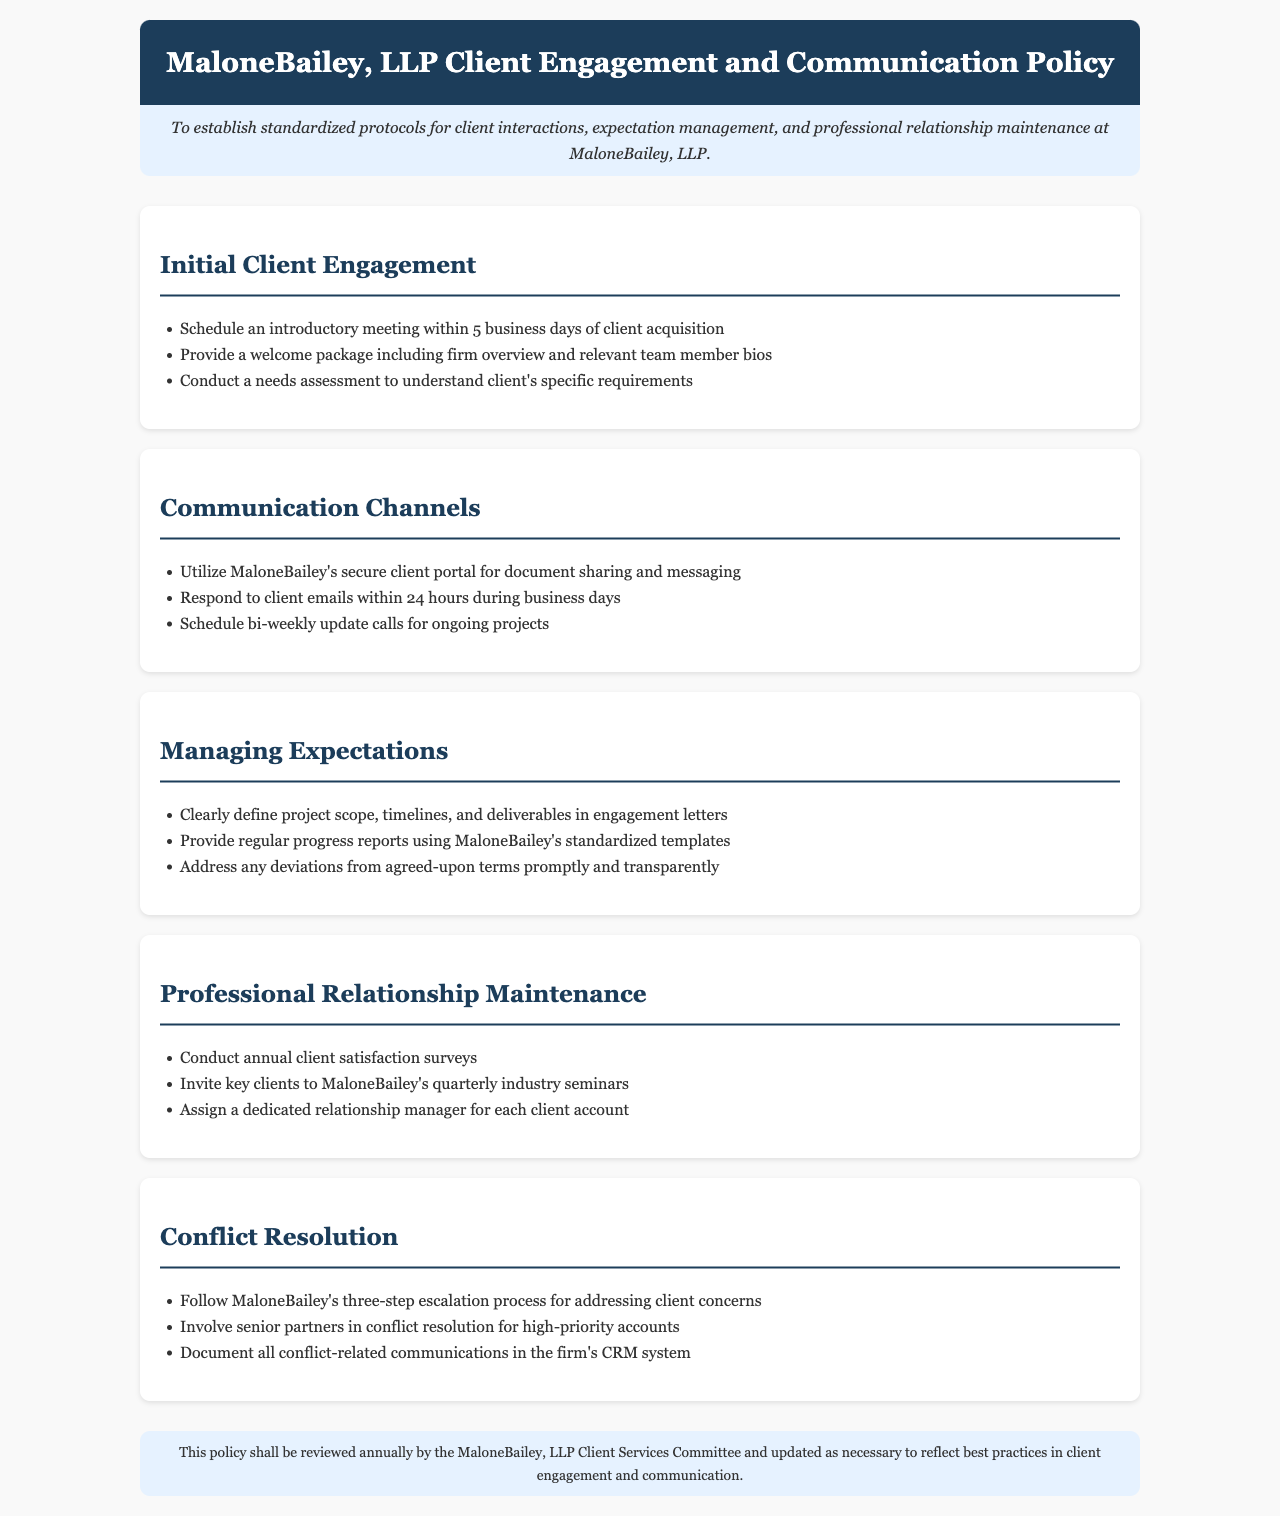What is the purpose of the policy? The purpose is to establish standardized protocols for client interactions, expectation management, and professional relationship maintenance at MaloneBailey, LLP.
Answer: To establish standardized protocols for client interactions, expectation management, and professional relationship maintenance at MaloneBailey, LLP What is the timeframe to schedule an introductory meeting? The document states that an introductory meeting should be scheduled within 5 business days of client acquisition.
Answer: 5 business days What communication channel is recommended for document sharing? The document specifies the use of MaloneBailey's secure client portal for document sharing and messaging.
Answer: MaloneBailey's secure client portal How often should update calls be scheduled? According to the policy, update calls for ongoing projects should be scheduled bi-weekly.
Answer: bi-weekly What is the approach for managing deviations from agreed-upon terms? The document indicates that deviations should be addressed promptly and transparently.
Answer: Promptly and transparently How frequently should client satisfaction surveys be conducted? The policy states that client satisfaction surveys should be conducted annually.
Answer: Annually What is the role of a dedicated relationship manager? The policy mentions that a dedicated relationship manager should be assigned for each client account.
Answer: Assigned for each client account What process is to be followed for conflict resolution? The document describes a three-step escalation process for addressing client concerns.
Answer: Three-step escalation process Who should be involved in conflict resolution for high-priority accounts? The document specifies that senior partners should be involved in conflict resolution for high-priority accounts.
Answer: Senior partners 